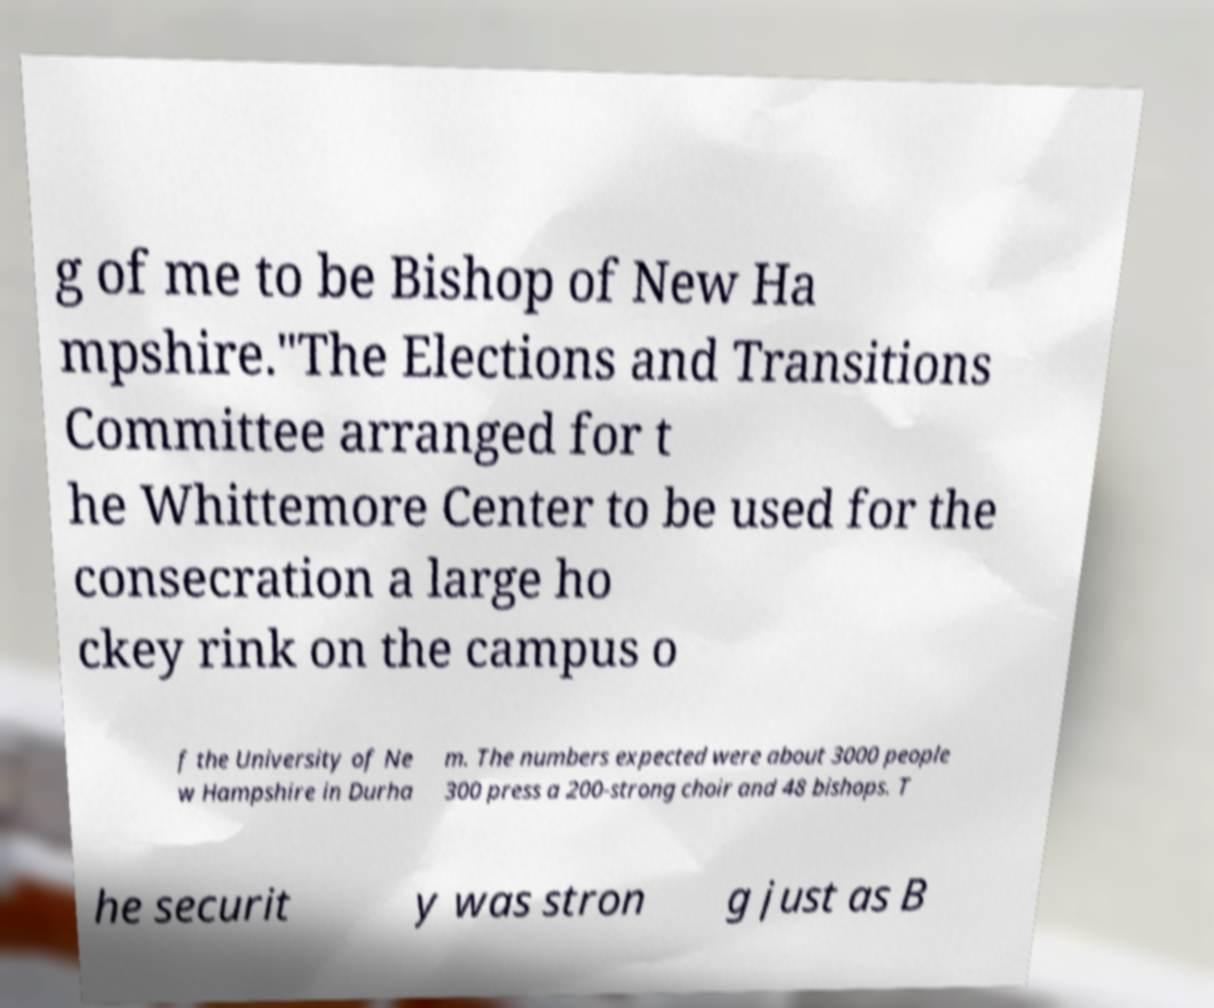Could you assist in decoding the text presented in this image and type it out clearly? g of me to be Bishop of New Ha mpshire."The Elections and Transitions Committee arranged for t he Whittemore Center to be used for the consecration a large ho ckey rink on the campus o f the University of Ne w Hampshire in Durha m. The numbers expected were about 3000 people 300 press a 200-strong choir and 48 bishops. T he securit y was stron g just as B 